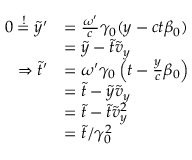Convert formula to latex. <formula><loc_0><loc_0><loc_500><loc_500>\begin{array} { r l } { 0 \overset { ! } { = } \tilde { y } ^ { \prime } } & { = \frac { \omega ^ { \prime } } { c } \gamma _ { 0 } ( y - c t \beta _ { 0 } ) } \\ & { = \tilde { y } - \tilde { t } \tilde { v } _ { y } } \\ { \Rightarrow \tilde { t } ^ { \prime } } & { = \omega ^ { \prime } \gamma _ { 0 } \left ( t - \frac { y } { c } \beta _ { 0 } \right ) } \\ & { = \tilde { t } - \tilde { y } \tilde { v } _ { y } } \\ & { = \tilde { t } - \tilde { t } \tilde { v } _ { y } ^ { 2 } } \\ & { = \tilde { t } / \gamma _ { 0 } ^ { 2 } } \end{array}</formula> 